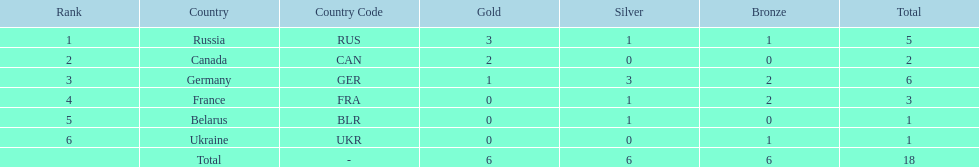Which country won the same amount of silver medals as the french and the russians? Belarus. 